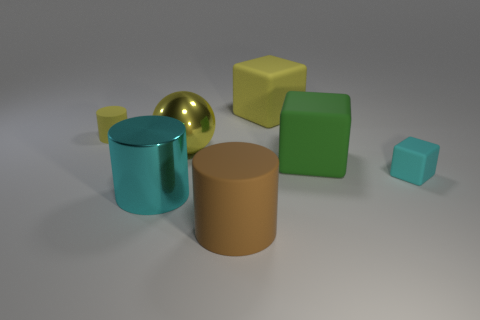Do the matte object that is behind the yellow matte cylinder and the large green thing have the same size?
Ensure brevity in your answer.  Yes. Is the small matte block the same color as the big metallic cylinder?
Provide a short and direct response. Yes. How many objects are both behind the green matte object and left of the yellow shiny ball?
Provide a succinct answer. 1. How many large cubes are in front of the big rubber object to the right of the yellow rubber thing that is right of the tiny yellow cylinder?
Provide a succinct answer. 0. The object that is the same color as the metal cylinder is what size?
Offer a very short reply. Small. What is the shape of the green rubber thing?
Your response must be concise. Cube. What number of purple objects have the same material as the large brown cylinder?
Offer a very short reply. 0. There is a tiny cylinder that is the same material as the big yellow cube; what is its color?
Offer a terse response. Yellow. There is a metal cylinder; is it the same size as the brown rubber cylinder that is in front of the big yellow metal thing?
Your response must be concise. Yes. The big yellow sphere that is behind the big block in front of the big matte object behind the yellow metallic object is made of what material?
Keep it short and to the point. Metal. 